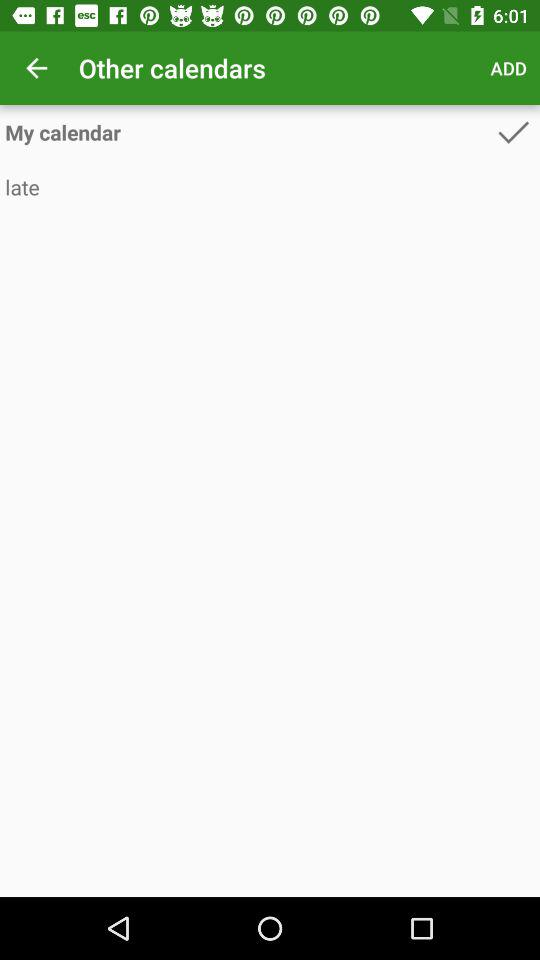Which option is checked? The checked option is "My calendar". 